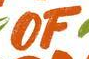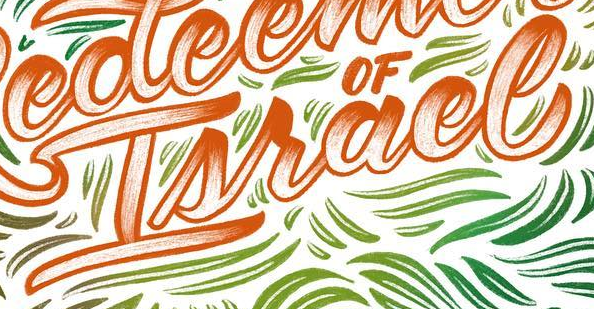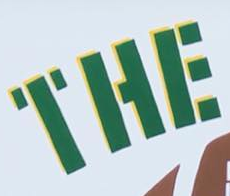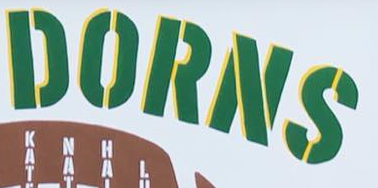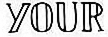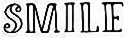Read the text content from these images in order, separated by a semicolon. OF; Israel; THE; DORNS; YOUR; SMILE 